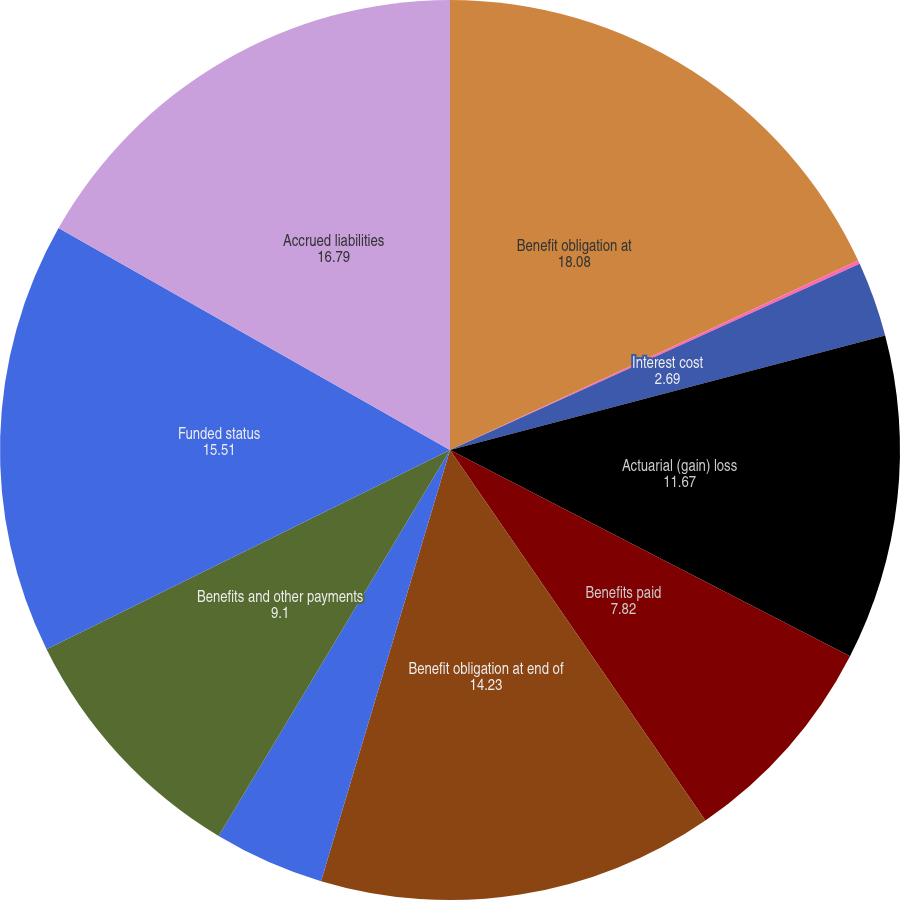Convert chart. <chart><loc_0><loc_0><loc_500><loc_500><pie_chart><fcel>Benefit obligation at<fcel>Service cost<fcel>Interest cost<fcel>Actuarial (gain) loss<fcel>Benefits paid<fcel>Benefit obligation at end of<fcel>Employer contributions<fcel>Benefits and other payments<fcel>Funded status<fcel>Accrued liabilities<nl><fcel>18.08%<fcel>0.13%<fcel>2.69%<fcel>11.67%<fcel>7.82%<fcel>14.23%<fcel>3.97%<fcel>9.1%<fcel>15.51%<fcel>16.79%<nl></chart> 